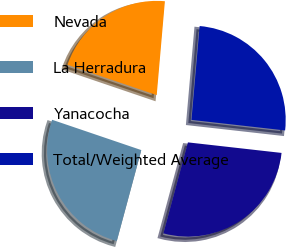Convert chart. <chart><loc_0><loc_0><loc_500><loc_500><pie_chart><fcel>Nevada<fcel>La Herradura<fcel>Yanacocha<fcel>Total/Weighted Average<nl><fcel>21.17%<fcel>26.02%<fcel>27.41%<fcel>25.4%<nl></chart> 